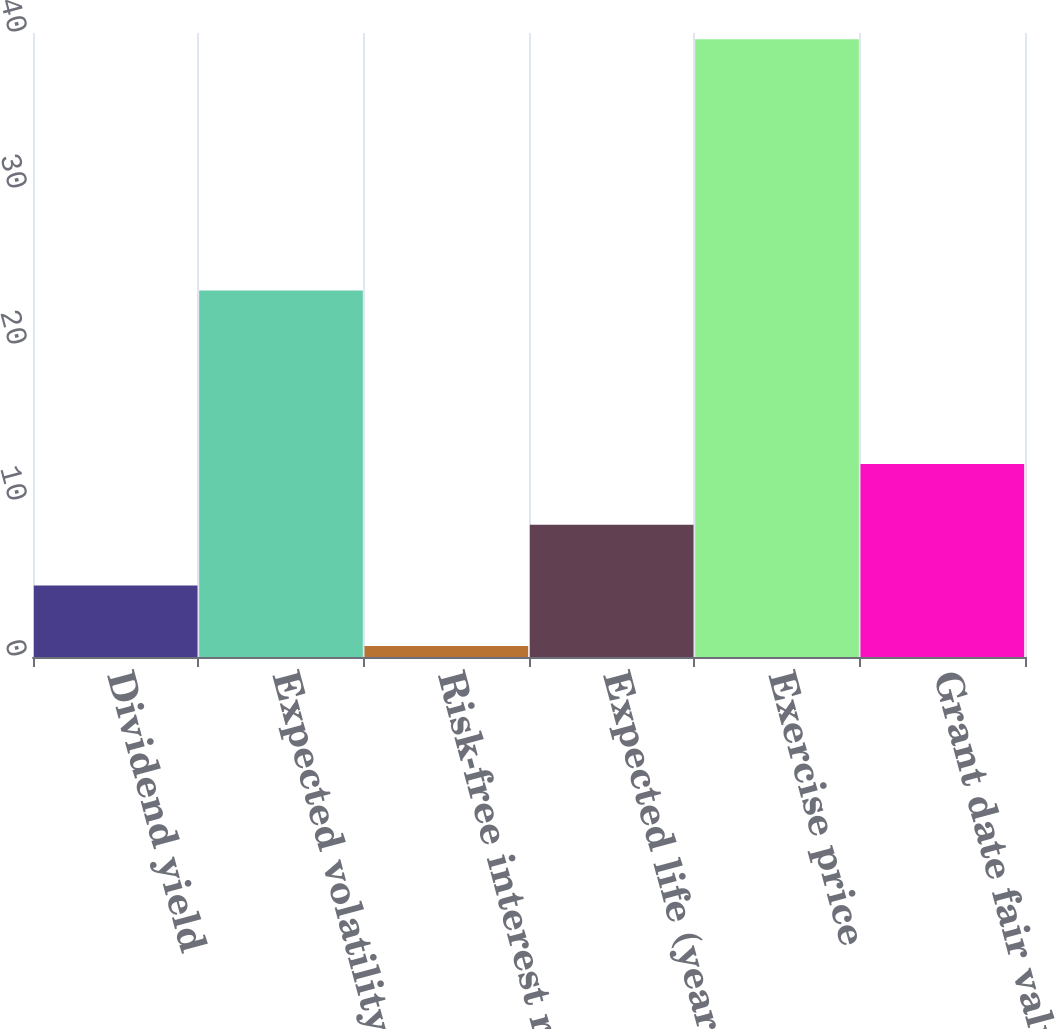<chart> <loc_0><loc_0><loc_500><loc_500><bar_chart><fcel>Dividend yield<fcel>Expected volatility<fcel>Risk-free interest rate<fcel>Expected life (years)<fcel>Exercise price<fcel>Grant date fair value per<nl><fcel>4.59<fcel>23.5<fcel>0.7<fcel>8.48<fcel>39.6<fcel>12.37<nl></chart> 